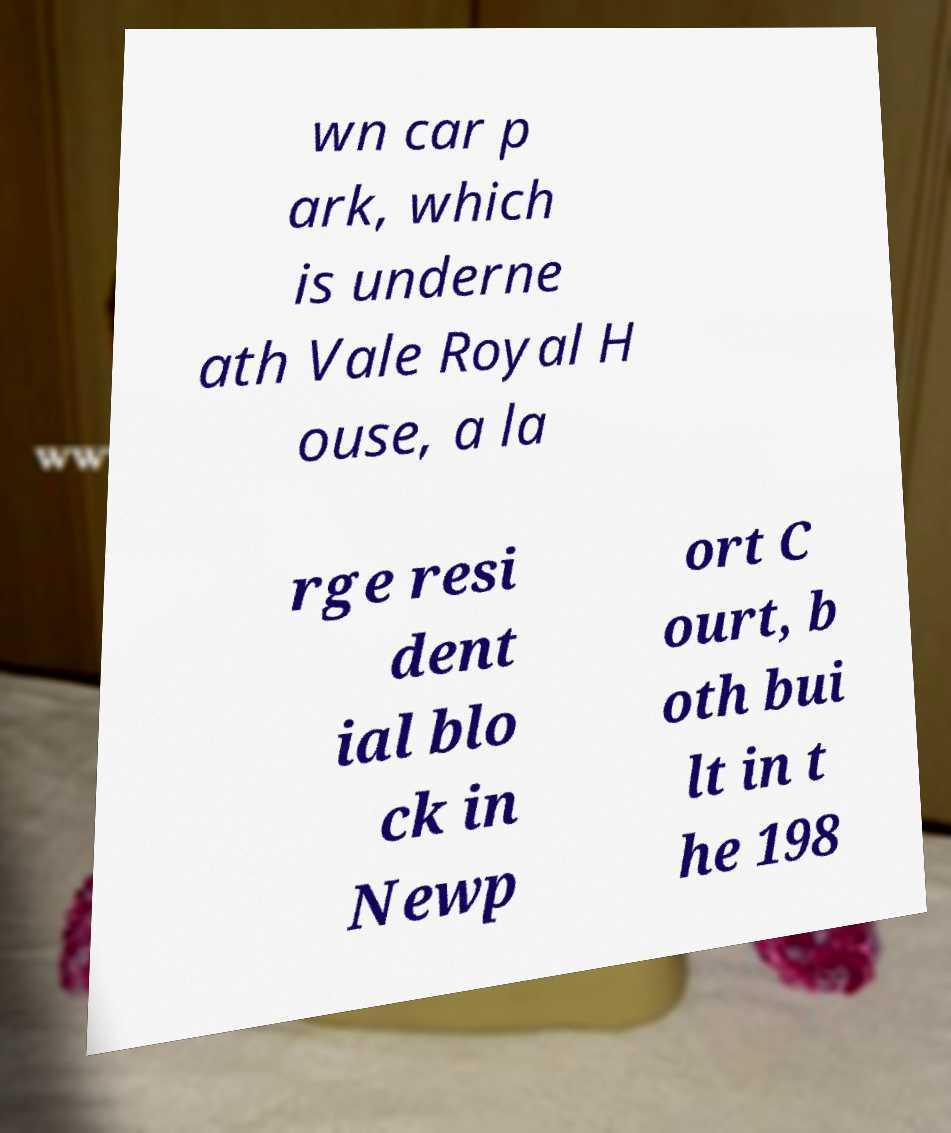Please identify and transcribe the text found in this image. wn car p ark, which is underne ath Vale Royal H ouse, a la rge resi dent ial blo ck in Newp ort C ourt, b oth bui lt in t he 198 